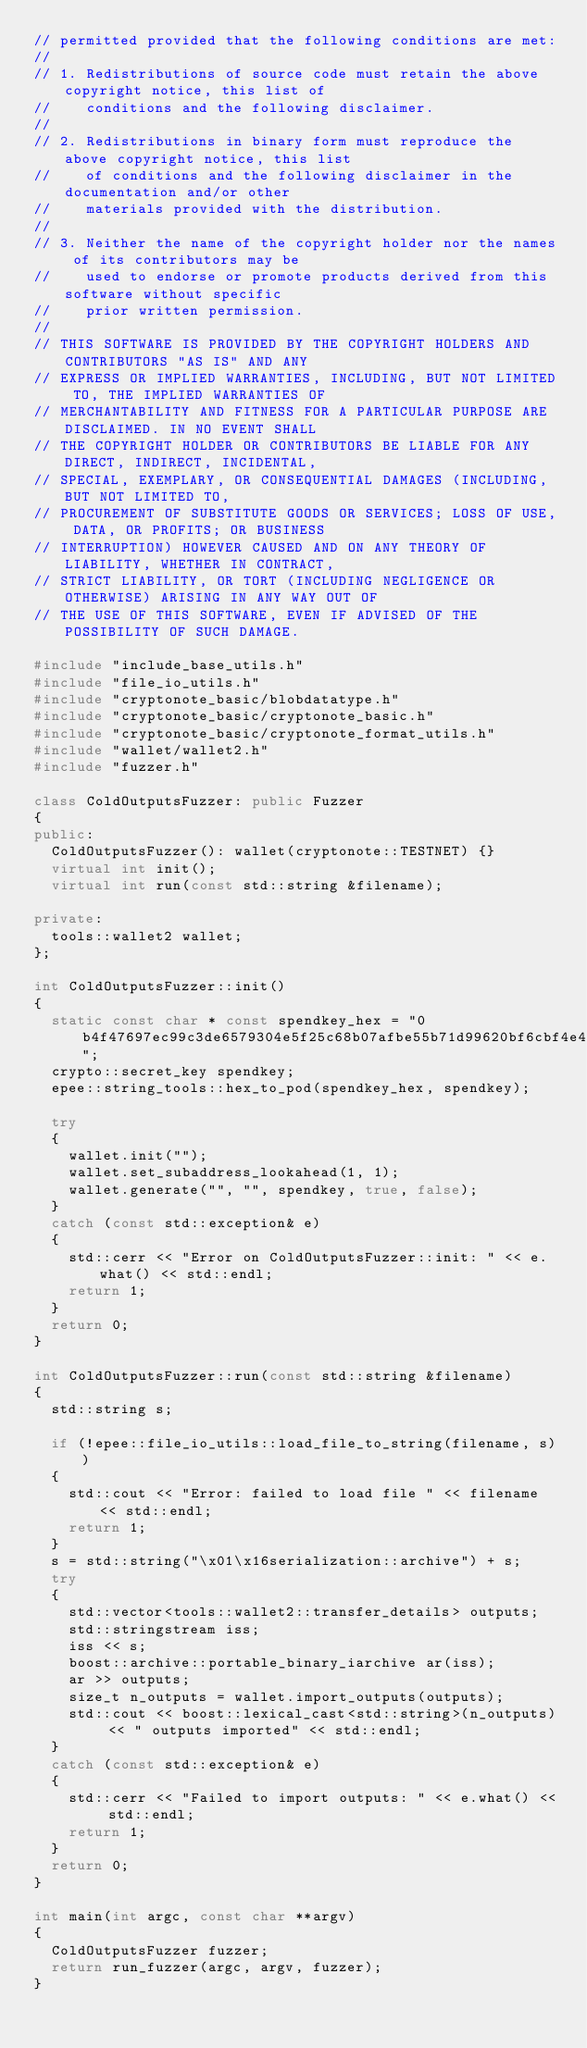<code> <loc_0><loc_0><loc_500><loc_500><_C++_>// permitted provided that the following conditions are met:
//
// 1. Redistributions of source code must retain the above copyright notice, this list of
//    conditions and the following disclaimer.
//
// 2. Redistributions in binary form must reproduce the above copyright notice, this list
//    of conditions and the following disclaimer in the documentation and/or other
//    materials provided with the distribution.
//
// 3. Neither the name of the copyright holder nor the names of its contributors may be
//    used to endorse or promote products derived from this software without specific
//    prior written permission.
//
// THIS SOFTWARE IS PROVIDED BY THE COPYRIGHT HOLDERS AND CONTRIBUTORS "AS IS" AND ANY
// EXPRESS OR IMPLIED WARRANTIES, INCLUDING, BUT NOT LIMITED TO, THE IMPLIED WARRANTIES OF
// MERCHANTABILITY AND FITNESS FOR A PARTICULAR PURPOSE ARE DISCLAIMED. IN NO EVENT SHALL
// THE COPYRIGHT HOLDER OR CONTRIBUTORS BE LIABLE FOR ANY DIRECT, INDIRECT, INCIDENTAL,
// SPECIAL, EXEMPLARY, OR CONSEQUENTIAL DAMAGES (INCLUDING, BUT NOT LIMITED TO,
// PROCUREMENT OF SUBSTITUTE GOODS OR SERVICES; LOSS OF USE, DATA, OR PROFITS; OR BUSINESS
// INTERRUPTION) HOWEVER CAUSED AND ON ANY THEORY OF LIABILITY, WHETHER IN CONTRACT,
// STRICT LIABILITY, OR TORT (INCLUDING NEGLIGENCE OR OTHERWISE) ARISING IN ANY WAY OUT OF
// THE USE OF THIS SOFTWARE, EVEN IF ADVISED OF THE POSSIBILITY OF SUCH DAMAGE.

#include "include_base_utils.h"
#include "file_io_utils.h"
#include "cryptonote_basic/blobdatatype.h"
#include "cryptonote_basic/cryptonote_basic.h"
#include "cryptonote_basic/cryptonote_format_utils.h"
#include "wallet/wallet2.h"
#include "fuzzer.h"

class ColdOutputsFuzzer: public Fuzzer
{
public:
  ColdOutputsFuzzer(): wallet(cryptonote::TESTNET) {}
  virtual int init();
  virtual int run(const std::string &filename);

private:
  tools::wallet2 wallet;
};

int ColdOutputsFuzzer::init()
{
  static const char * const spendkey_hex = "0b4f47697ec99c3de6579304e5f25c68b07afbe55b71d99620bf6cbf4e45a80f";
  crypto::secret_key spendkey;
  epee::string_tools::hex_to_pod(spendkey_hex, spendkey);

  try
  {
    wallet.init("");
    wallet.set_subaddress_lookahead(1, 1);
    wallet.generate("", "", spendkey, true, false);
  }
  catch (const std::exception& e)
  {
    std::cerr << "Error on ColdOutputsFuzzer::init: " << e.what() << std::endl;
    return 1;
  }
  return 0;
}

int ColdOutputsFuzzer::run(const std::string &filename)
{
  std::string s;

  if (!epee::file_io_utils::load_file_to_string(filename, s))
  {
    std::cout << "Error: failed to load file " << filename << std::endl;
    return 1;
  }
  s = std::string("\x01\x16serialization::archive") + s;
  try
  {
    std::vector<tools::wallet2::transfer_details> outputs;
    std::stringstream iss;
    iss << s;
    boost::archive::portable_binary_iarchive ar(iss);
    ar >> outputs;
    size_t n_outputs = wallet.import_outputs(outputs);
    std::cout << boost::lexical_cast<std::string>(n_outputs) << " outputs imported" << std::endl;
  }
  catch (const std::exception& e)
  {
    std::cerr << "Failed to import outputs: " << e.what() << std::endl;
    return 1;
  }
  return 0;
}

int main(int argc, const char **argv)
{
  ColdOutputsFuzzer fuzzer;
  return run_fuzzer(argc, argv, fuzzer);
}
</code> 